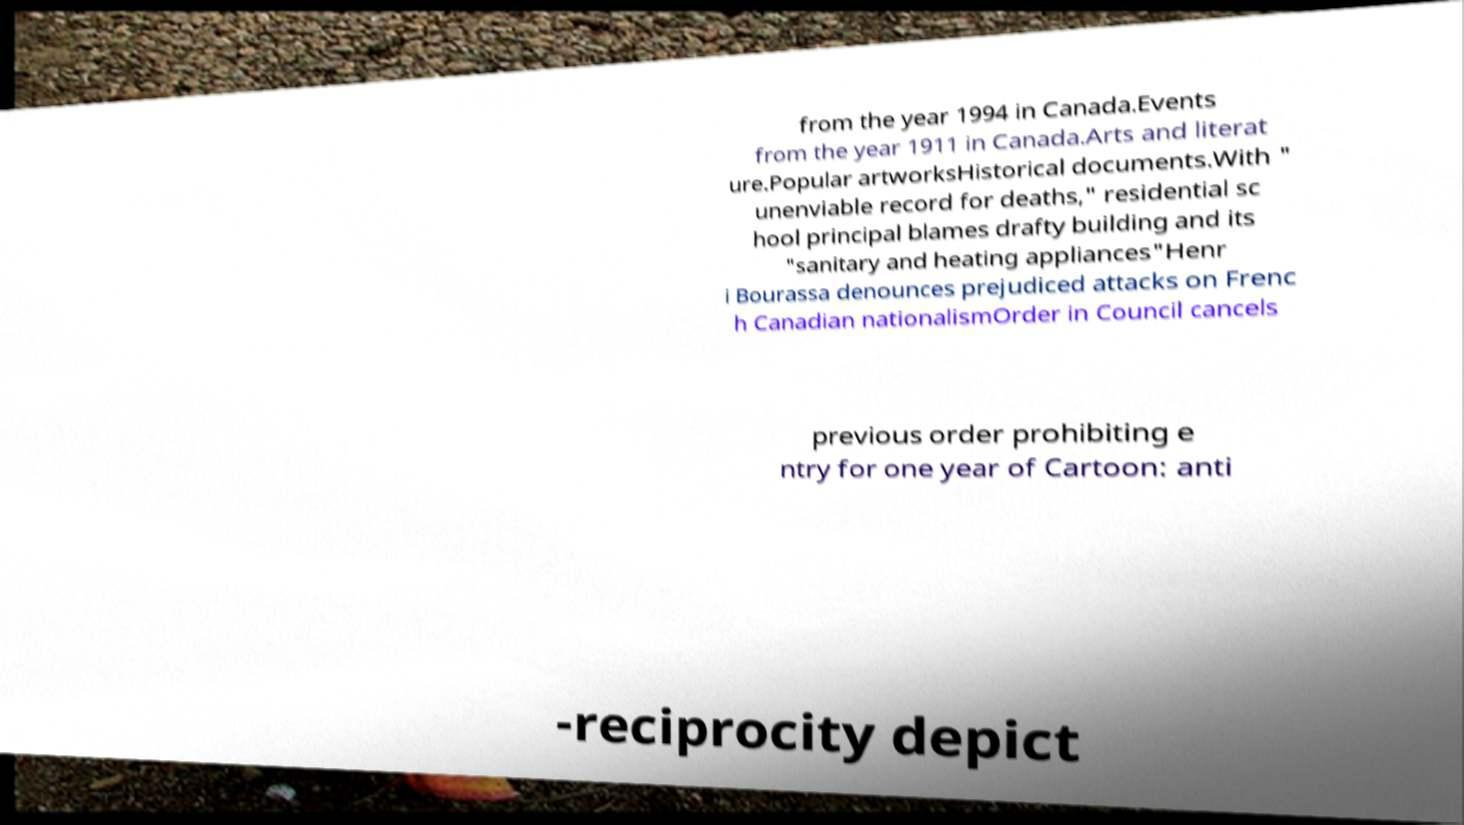Please identify and transcribe the text found in this image. from the year 1994 in Canada.Events from the year 1911 in Canada.Arts and literat ure.Popular artworksHistorical documents.With " unenviable record for deaths," residential sc hool principal blames drafty building and its "sanitary and heating appliances"Henr i Bourassa denounces prejudiced attacks on Frenc h Canadian nationalismOrder in Council cancels previous order prohibiting e ntry for one year of Cartoon: anti -reciprocity depict 